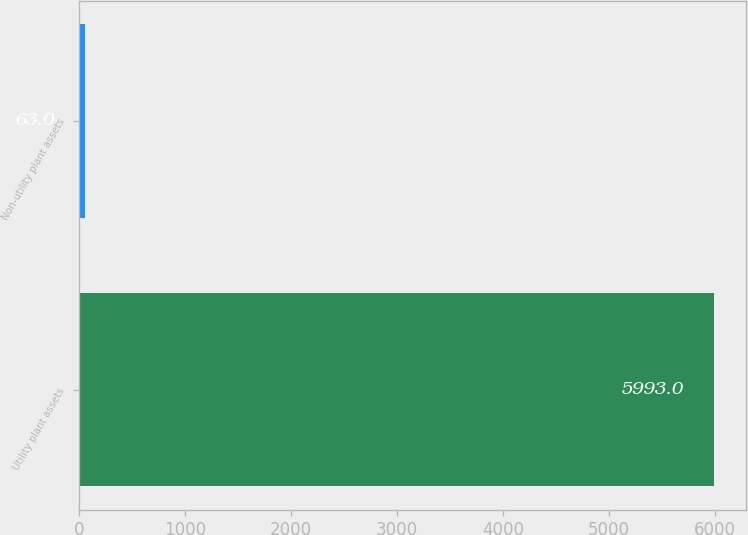<chart> <loc_0><loc_0><loc_500><loc_500><bar_chart><fcel>Utility plant assets<fcel>Non-utility plant assets<nl><fcel>5993<fcel>63<nl></chart> 